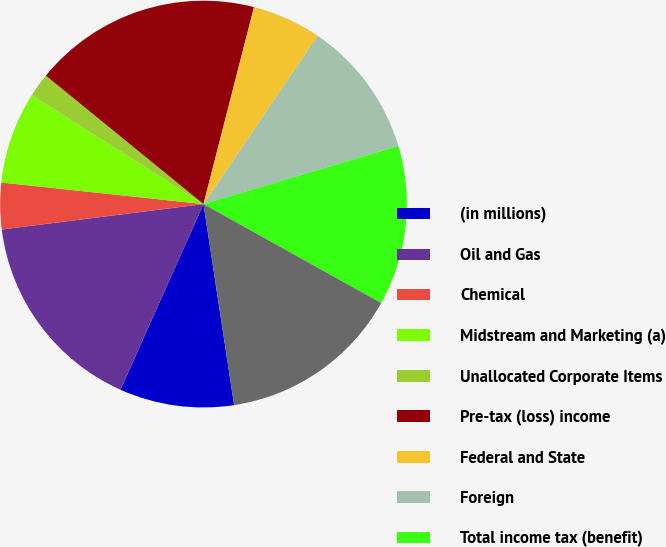<chart> <loc_0><loc_0><loc_500><loc_500><pie_chart><fcel>(in millions)<fcel>Oil and Gas<fcel>Chemical<fcel>Midstream and Marketing (a)<fcel>Unallocated Corporate Items<fcel>Pre-tax (loss) income<fcel>Federal and State<fcel>Foreign<fcel>Total income tax (benefit)<fcel>Income (loss) from continuing<nl><fcel>9.1%<fcel>16.31%<fcel>3.69%<fcel>7.3%<fcel>1.89%<fcel>18.11%<fcel>5.49%<fcel>10.9%<fcel>12.7%<fcel>14.51%<nl></chart> 